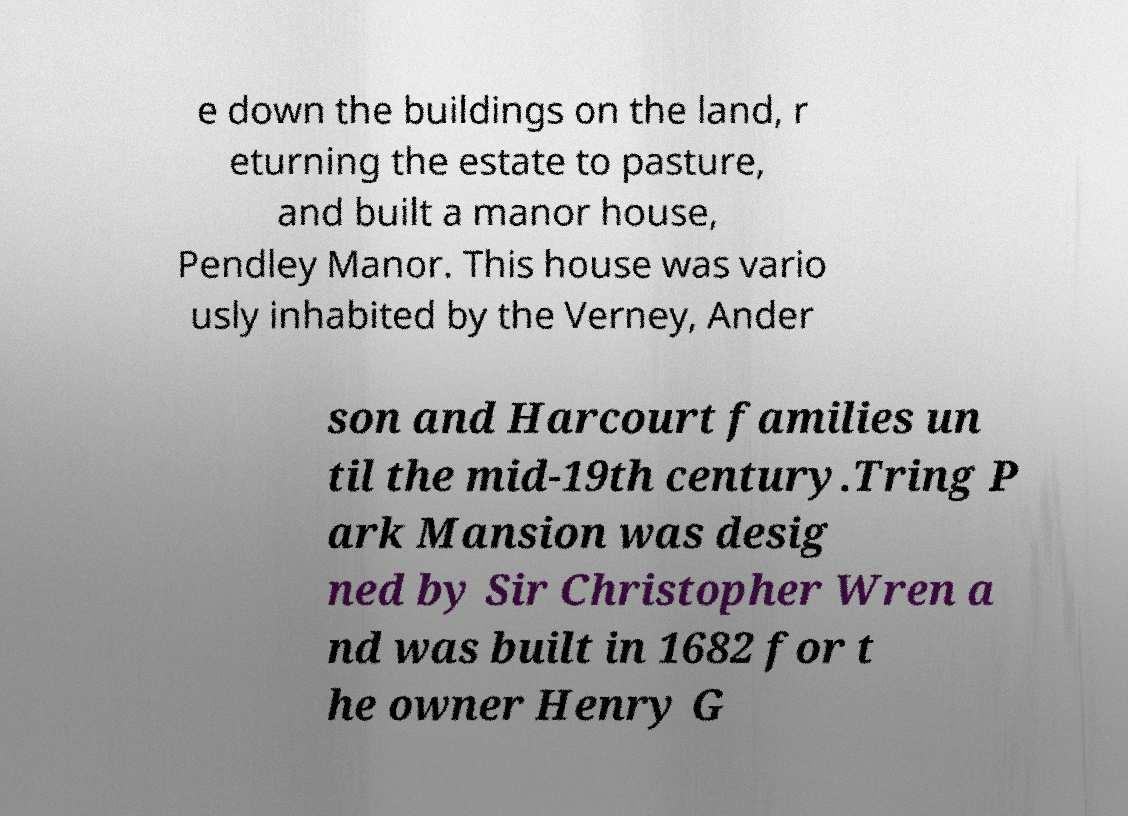I need the written content from this picture converted into text. Can you do that? e down the buildings on the land, r eturning the estate to pasture, and built a manor house, Pendley Manor. This house was vario usly inhabited by the Verney, Ander son and Harcourt families un til the mid-19th century.Tring P ark Mansion was desig ned by Sir Christopher Wren a nd was built in 1682 for t he owner Henry G 